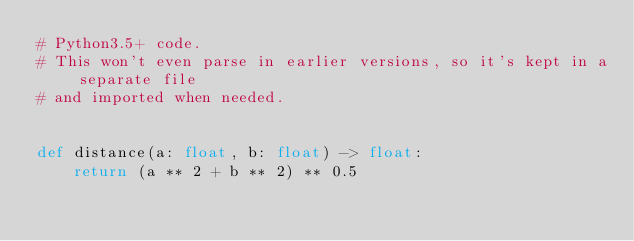<code> <loc_0><loc_0><loc_500><loc_500><_Python_># Python3.5+ code.
# This won't even parse in earlier versions, so it's kept in a separate file
# and imported when needed.


def distance(a: float, b: float) -> float:
    return (a ** 2 + b ** 2) ** 0.5
</code> 